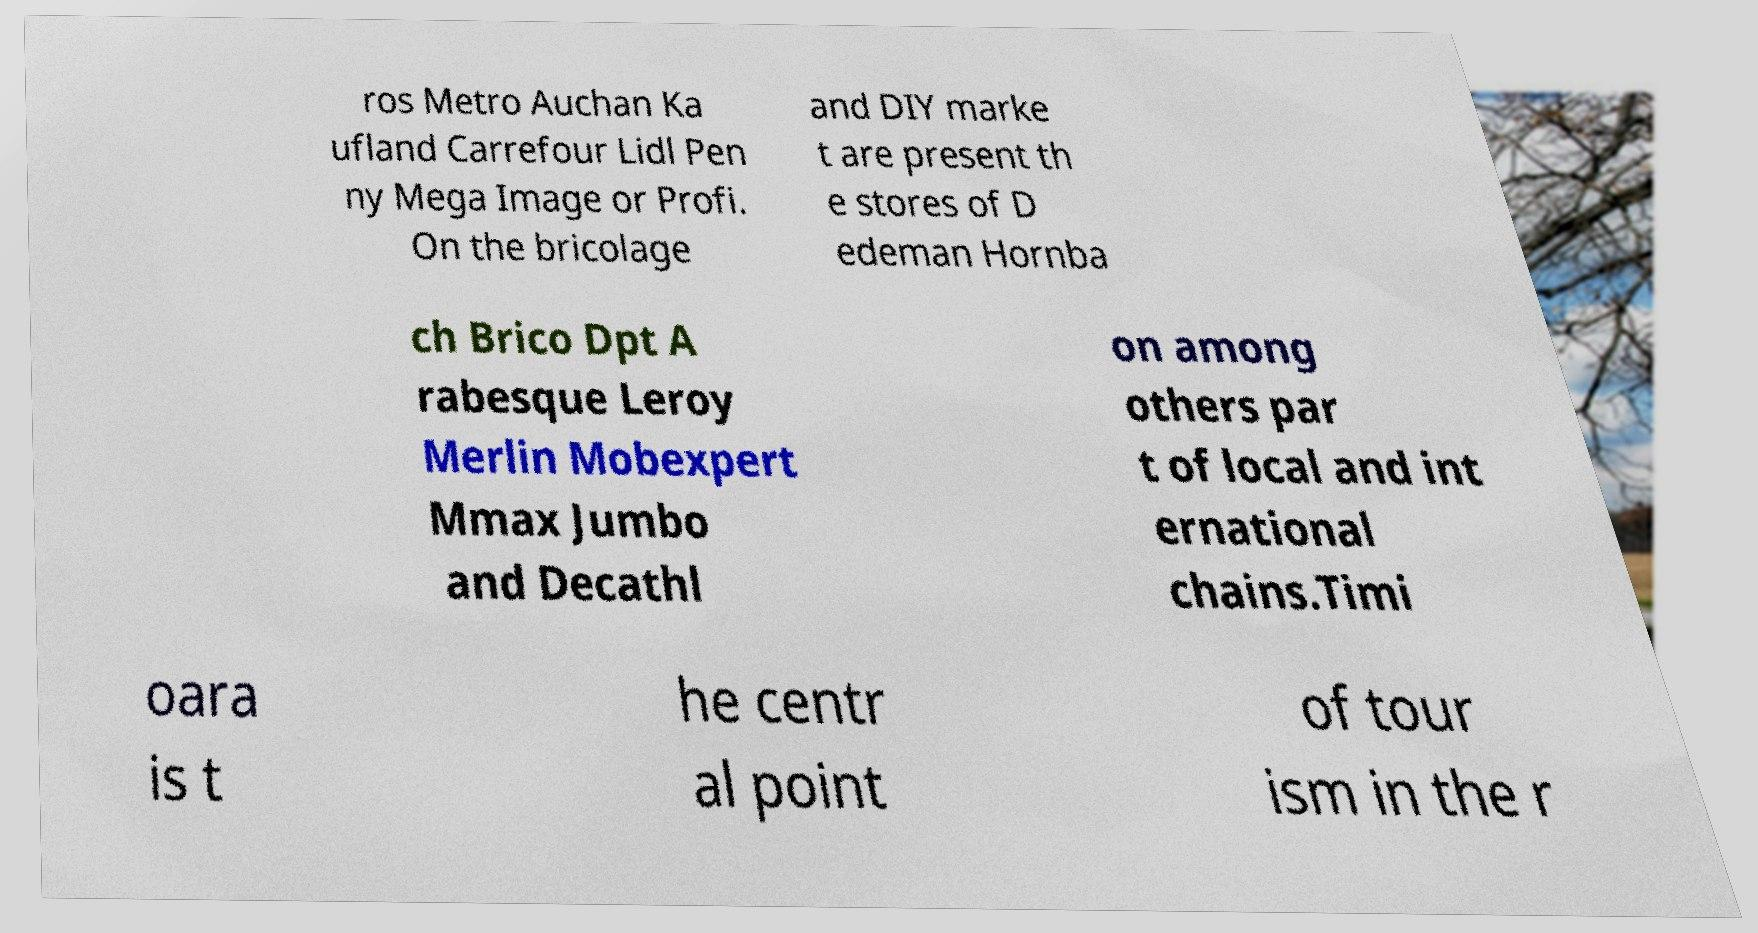I need the written content from this picture converted into text. Can you do that? ros Metro Auchan Ka ufland Carrefour Lidl Pen ny Mega Image or Profi. On the bricolage and DIY marke t are present th e stores of D edeman Hornba ch Brico Dpt A rabesque Leroy Merlin Mobexpert Mmax Jumbo and Decathl on among others par t of local and int ernational chains.Timi oara is t he centr al point of tour ism in the r 